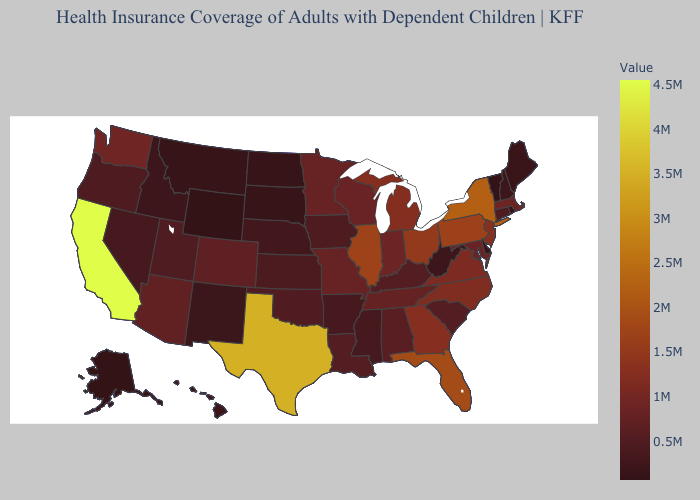Does Pennsylvania have the lowest value in the USA?
Quick response, please. No. Among the states that border Missouri , which have the highest value?
Write a very short answer. Illinois. Does Texas have the highest value in the South?
Quick response, please. Yes. Among the states that border Colorado , does Oklahoma have the highest value?
Give a very brief answer. No. Does California have the highest value in the USA?
Quick response, please. Yes. Which states have the highest value in the USA?
Give a very brief answer. California. 